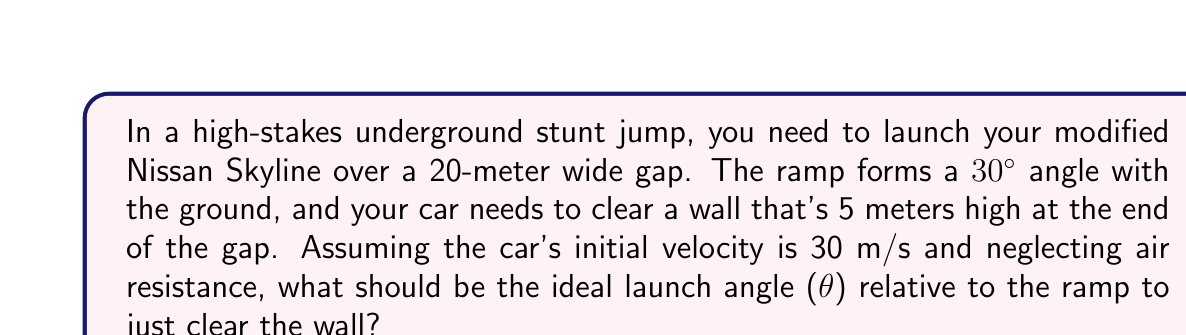Solve this math problem. Let's approach this step-by-step:

1) First, we need to consider the car's motion in two components: horizontal and vertical.

2) The initial velocity components are:
   $v_x = v \cos(\theta + 30°)$
   $v_y = v \sin(\theta + 30°)$

3) The time to travel the horizontal distance is:
   $t = \frac{20}{v \cos(\theta + 30°)}$

4) The vertical displacement after time t is given by:
   $y = v_y t - \frac{1}{2}gt^2$

5) Substituting the expressions for $v_y$ and $t$:
   $y = v \sin(\theta + 30°) \cdot \frac{20}{v \cos(\theta + 30°)} - \frac{1}{2}g(\frac{20}{v \cos(\theta + 30°)})^2$

6) Simplify:
   $y = 20 \tan(\theta + 30°) - \frac{200g}{2v^2\cos^2(\theta + 30°)}$

7) We want y to equal 5 (the height of the wall). Substituting known values (g = 9.8 m/s², v = 30 m/s):
   $5 = 20 \tan(\theta + 30°) - \frac{200 \cdot 9.8}{2 \cdot 30^2\cos^2(\theta + 30°)}$

8) This equation can be solved numerically. Using a graphing calculator or numerical methods, we find:
   $\theta \approx 10.8°$

Therefore, the launch angle relative to the ramp should be about 10.8°.
Answer: $10.8°$ 